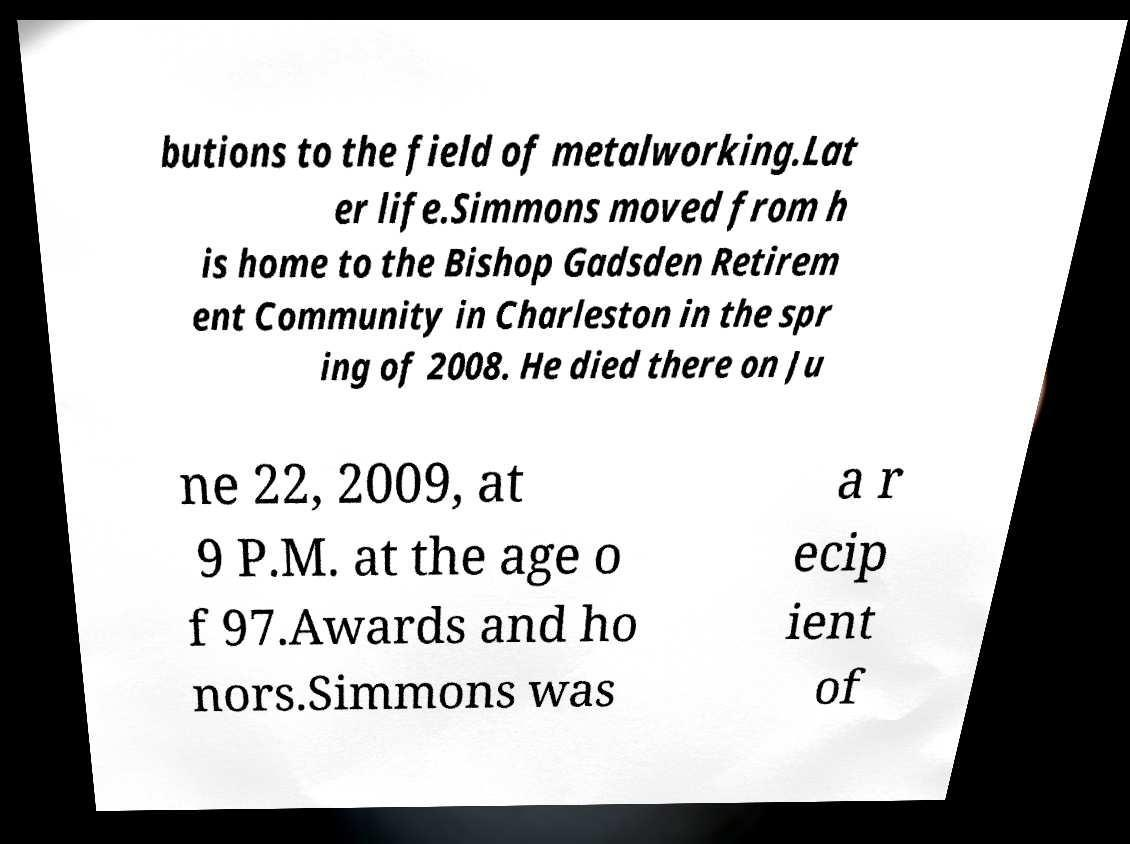There's text embedded in this image that I need extracted. Can you transcribe it verbatim? butions to the field of metalworking.Lat er life.Simmons moved from h is home to the Bishop Gadsden Retirem ent Community in Charleston in the spr ing of 2008. He died there on Ju ne 22, 2009, at 9 P.M. at the age o f 97.Awards and ho nors.Simmons was a r ecip ient of 